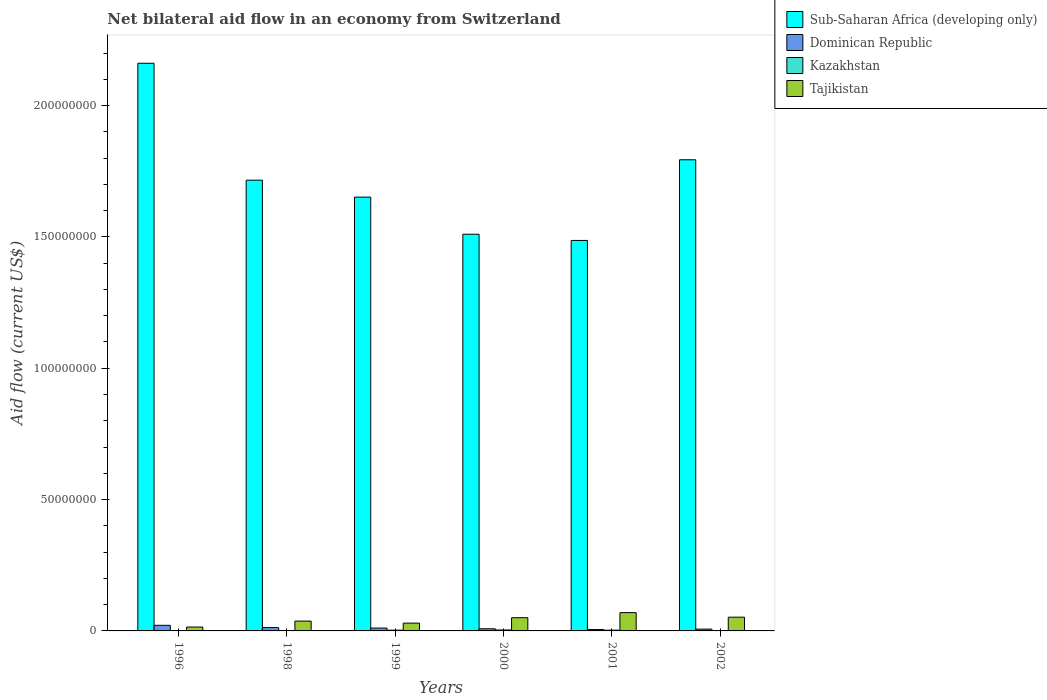How many different coloured bars are there?
Your answer should be very brief. 4. How many bars are there on the 1st tick from the left?
Make the answer very short. 4. What is the label of the 2nd group of bars from the left?
Your answer should be very brief. 1998. What is the net bilateral aid flow in Dominican Republic in 1998?
Make the answer very short. 1.27e+06. Across all years, what is the maximum net bilateral aid flow in Sub-Saharan Africa (developing only)?
Keep it short and to the point. 2.16e+08. In which year was the net bilateral aid flow in Dominican Republic minimum?
Offer a terse response. 2001. What is the total net bilateral aid flow in Sub-Saharan Africa (developing only) in the graph?
Offer a terse response. 1.03e+09. What is the difference between the net bilateral aid flow in Sub-Saharan Africa (developing only) in 1996 and the net bilateral aid flow in Tajikistan in 1999?
Ensure brevity in your answer.  2.13e+08. What is the average net bilateral aid flow in Sub-Saharan Africa (developing only) per year?
Offer a very short reply. 1.72e+08. In the year 2001, what is the difference between the net bilateral aid flow in Tajikistan and net bilateral aid flow in Sub-Saharan Africa (developing only)?
Make the answer very short. -1.42e+08. What is the ratio of the net bilateral aid flow in Kazakhstan in 1998 to that in 2001?
Make the answer very short. 0.25. Is the net bilateral aid flow in Kazakhstan in 1996 less than that in 2002?
Keep it short and to the point. Yes. What is the difference between the highest and the second highest net bilateral aid flow in Tajikistan?
Keep it short and to the point. 1.74e+06. What is the difference between the highest and the lowest net bilateral aid flow in Dominican Republic?
Give a very brief answer. 1.61e+06. In how many years, is the net bilateral aid flow in Dominican Republic greater than the average net bilateral aid flow in Dominican Republic taken over all years?
Give a very brief answer. 3. Is it the case that in every year, the sum of the net bilateral aid flow in Sub-Saharan Africa (developing only) and net bilateral aid flow in Dominican Republic is greater than the sum of net bilateral aid flow in Tajikistan and net bilateral aid flow in Kazakhstan?
Provide a succinct answer. No. What does the 3rd bar from the left in 1999 represents?
Keep it short and to the point. Kazakhstan. What does the 1st bar from the right in 2002 represents?
Offer a terse response. Tajikistan. Is it the case that in every year, the sum of the net bilateral aid flow in Sub-Saharan Africa (developing only) and net bilateral aid flow in Dominican Republic is greater than the net bilateral aid flow in Tajikistan?
Give a very brief answer. Yes. How many bars are there?
Offer a very short reply. 24. Does the graph contain any zero values?
Your answer should be very brief. No. Does the graph contain grids?
Keep it short and to the point. No. Where does the legend appear in the graph?
Keep it short and to the point. Top right. How many legend labels are there?
Give a very brief answer. 4. How are the legend labels stacked?
Ensure brevity in your answer.  Vertical. What is the title of the graph?
Offer a terse response. Net bilateral aid flow in an economy from Switzerland. What is the label or title of the X-axis?
Give a very brief answer. Years. What is the label or title of the Y-axis?
Your response must be concise. Aid flow (current US$). What is the Aid flow (current US$) in Sub-Saharan Africa (developing only) in 1996?
Your answer should be very brief. 2.16e+08. What is the Aid flow (current US$) of Dominican Republic in 1996?
Give a very brief answer. 2.13e+06. What is the Aid flow (current US$) of Kazakhstan in 1996?
Provide a succinct answer. 3.00e+04. What is the Aid flow (current US$) in Tajikistan in 1996?
Offer a very short reply. 1.48e+06. What is the Aid flow (current US$) in Sub-Saharan Africa (developing only) in 1998?
Give a very brief answer. 1.72e+08. What is the Aid flow (current US$) in Dominican Republic in 1998?
Your answer should be very brief. 1.27e+06. What is the Aid flow (current US$) in Tajikistan in 1998?
Provide a short and direct response. 3.74e+06. What is the Aid flow (current US$) of Sub-Saharan Africa (developing only) in 1999?
Provide a short and direct response. 1.65e+08. What is the Aid flow (current US$) in Dominican Republic in 1999?
Make the answer very short. 1.09e+06. What is the Aid flow (current US$) in Tajikistan in 1999?
Offer a terse response. 2.97e+06. What is the Aid flow (current US$) of Sub-Saharan Africa (developing only) in 2000?
Provide a succinct answer. 1.51e+08. What is the Aid flow (current US$) in Dominican Republic in 2000?
Offer a very short reply. 8.10e+05. What is the Aid flow (current US$) in Tajikistan in 2000?
Offer a very short reply. 5.04e+06. What is the Aid flow (current US$) in Sub-Saharan Africa (developing only) in 2001?
Give a very brief answer. 1.49e+08. What is the Aid flow (current US$) in Dominican Republic in 2001?
Your answer should be compact. 5.20e+05. What is the Aid flow (current US$) in Kazakhstan in 2001?
Provide a succinct answer. 2.80e+05. What is the Aid flow (current US$) of Tajikistan in 2001?
Your answer should be compact. 6.97e+06. What is the Aid flow (current US$) in Sub-Saharan Africa (developing only) in 2002?
Keep it short and to the point. 1.79e+08. What is the Aid flow (current US$) of Dominican Republic in 2002?
Your answer should be compact. 6.80e+05. What is the Aid flow (current US$) in Tajikistan in 2002?
Provide a succinct answer. 5.23e+06. Across all years, what is the maximum Aid flow (current US$) in Sub-Saharan Africa (developing only)?
Ensure brevity in your answer.  2.16e+08. Across all years, what is the maximum Aid flow (current US$) of Dominican Republic?
Give a very brief answer. 2.13e+06. Across all years, what is the maximum Aid flow (current US$) in Tajikistan?
Keep it short and to the point. 6.97e+06. Across all years, what is the minimum Aid flow (current US$) of Sub-Saharan Africa (developing only)?
Offer a terse response. 1.49e+08. Across all years, what is the minimum Aid flow (current US$) of Dominican Republic?
Your answer should be very brief. 5.20e+05. Across all years, what is the minimum Aid flow (current US$) in Kazakhstan?
Provide a succinct answer. 3.00e+04. Across all years, what is the minimum Aid flow (current US$) of Tajikistan?
Offer a very short reply. 1.48e+06. What is the total Aid flow (current US$) of Sub-Saharan Africa (developing only) in the graph?
Your answer should be very brief. 1.03e+09. What is the total Aid flow (current US$) of Dominican Republic in the graph?
Make the answer very short. 6.50e+06. What is the total Aid flow (current US$) of Kazakhstan in the graph?
Your answer should be compact. 1.14e+06. What is the total Aid flow (current US$) in Tajikistan in the graph?
Your answer should be very brief. 2.54e+07. What is the difference between the Aid flow (current US$) in Sub-Saharan Africa (developing only) in 1996 and that in 1998?
Ensure brevity in your answer.  4.45e+07. What is the difference between the Aid flow (current US$) in Dominican Republic in 1996 and that in 1998?
Ensure brevity in your answer.  8.60e+05. What is the difference between the Aid flow (current US$) in Kazakhstan in 1996 and that in 1998?
Your answer should be compact. -4.00e+04. What is the difference between the Aid flow (current US$) in Tajikistan in 1996 and that in 1998?
Your answer should be compact. -2.26e+06. What is the difference between the Aid flow (current US$) in Sub-Saharan Africa (developing only) in 1996 and that in 1999?
Provide a succinct answer. 5.10e+07. What is the difference between the Aid flow (current US$) of Dominican Republic in 1996 and that in 1999?
Offer a terse response. 1.04e+06. What is the difference between the Aid flow (current US$) in Tajikistan in 1996 and that in 1999?
Your answer should be very brief. -1.49e+06. What is the difference between the Aid flow (current US$) of Sub-Saharan Africa (developing only) in 1996 and that in 2000?
Offer a terse response. 6.51e+07. What is the difference between the Aid flow (current US$) in Dominican Republic in 1996 and that in 2000?
Offer a very short reply. 1.32e+06. What is the difference between the Aid flow (current US$) of Kazakhstan in 1996 and that in 2000?
Your response must be concise. -3.30e+05. What is the difference between the Aid flow (current US$) in Tajikistan in 1996 and that in 2000?
Your response must be concise. -3.56e+06. What is the difference between the Aid flow (current US$) in Sub-Saharan Africa (developing only) in 1996 and that in 2001?
Ensure brevity in your answer.  6.74e+07. What is the difference between the Aid flow (current US$) of Dominican Republic in 1996 and that in 2001?
Give a very brief answer. 1.61e+06. What is the difference between the Aid flow (current US$) in Tajikistan in 1996 and that in 2001?
Your answer should be compact. -5.49e+06. What is the difference between the Aid flow (current US$) of Sub-Saharan Africa (developing only) in 1996 and that in 2002?
Give a very brief answer. 3.67e+07. What is the difference between the Aid flow (current US$) of Dominican Republic in 1996 and that in 2002?
Your answer should be very brief. 1.45e+06. What is the difference between the Aid flow (current US$) in Tajikistan in 1996 and that in 2002?
Your response must be concise. -3.75e+06. What is the difference between the Aid flow (current US$) of Sub-Saharan Africa (developing only) in 1998 and that in 1999?
Ensure brevity in your answer.  6.45e+06. What is the difference between the Aid flow (current US$) in Dominican Republic in 1998 and that in 1999?
Your answer should be compact. 1.80e+05. What is the difference between the Aid flow (current US$) of Tajikistan in 1998 and that in 1999?
Your answer should be very brief. 7.70e+05. What is the difference between the Aid flow (current US$) in Sub-Saharan Africa (developing only) in 1998 and that in 2000?
Give a very brief answer. 2.06e+07. What is the difference between the Aid flow (current US$) of Tajikistan in 1998 and that in 2000?
Give a very brief answer. -1.30e+06. What is the difference between the Aid flow (current US$) of Sub-Saharan Africa (developing only) in 1998 and that in 2001?
Provide a short and direct response. 2.29e+07. What is the difference between the Aid flow (current US$) in Dominican Republic in 1998 and that in 2001?
Provide a succinct answer. 7.50e+05. What is the difference between the Aid flow (current US$) in Tajikistan in 1998 and that in 2001?
Make the answer very short. -3.23e+06. What is the difference between the Aid flow (current US$) in Sub-Saharan Africa (developing only) in 1998 and that in 2002?
Provide a short and direct response. -7.77e+06. What is the difference between the Aid flow (current US$) in Dominican Republic in 1998 and that in 2002?
Offer a very short reply. 5.90e+05. What is the difference between the Aid flow (current US$) in Tajikistan in 1998 and that in 2002?
Offer a terse response. -1.49e+06. What is the difference between the Aid flow (current US$) in Sub-Saharan Africa (developing only) in 1999 and that in 2000?
Give a very brief answer. 1.41e+07. What is the difference between the Aid flow (current US$) in Tajikistan in 1999 and that in 2000?
Provide a succinct answer. -2.07e+06. What is the difference between the Aid flow (current US$) of Sub-Saharan Africa (developing only) in 1999 and that in 2001?
Offer a very short reply. 1.65e+07. What is the difference between the Aid flow (current US$) of Dominican Republic in 1999 and that in 2001?
Offer a terse response. 5.70e+05. What is the difference between the Aid flow (current US$) of Sub-Saharan Africa (developing only) in 1999 and that in 2002?
Make the answer very short. -1.42e+07. What is the difference between the Aid flow (current US$) in Kazakhstan in 1999 and that in 2002?
Your response must be concise. 1.60e+05. What is the difference between the Aid flow (current US$) of Tajikistan in 1999 and that in 2002?
Your answer should be very brief. -2.26e+06. What is the difference between the Aid flow (current US$) of Sub-Saharan Africa (developing only) in 2000 and that in 2001?
Offer a very short reply. 2.36e+06. What is the difference between the Aid flow (current US$) in Tajikistan in 2000 and that in 2001?
Make the answer very short. -1.93e+06. What is the difference between the Aid flow (current US$) of Sub-Saharan Africa (developing only) in 2000 and that in 2002?
Give a very brief answer. -2.84e+07. What is the difference between the Aid flow (current US$) of Kazakhstan in 2000 and that in 2002?
Offer a terse response. 2.40e+05. What is the difference between the Aid flow (current US$) of Sub-Saharan Africa (developing only) in 2001 and that in 2002?
Your answer should be compact. -3.07e+07. What is the difference between the Aid flow (current US$) of Kazakhstan in 2001 and that in 2002?
Offer a terse response. 1.60e+05. What is the difference between the Aid flow (current US$) of Tajikistan in 2001 and that in 2002?
Give a very brief answer. 1.74e+06. What is the difference between the Aid flow (current US$) in Sub-Saharan Africa (developing only) in 1996 and the Aid flow (current US$) in Dominican Republic in 1998?
Provide a succinct answer. 2.15e+08. What is the difference between the Aid flow (current US$) of Sub-Saharan Africa (developing only) in 1996 and the Aid flow (current US$) of Kazakhstan in 1998?
Offer a very short reply. 2.16e+08. What is the difference between the Aid flow (current US$) of Sub-Saharan Africa (developing only) in 1996 and the Aid flow (current US$) of Tajikistan in 1998?
Your response must be concise. 2.12e+08. What is the difference between the Aid flow (current US$) of Dominican Republic in 1996 and the Aid flow (current US$) of Kazakhstan in 1998?
Give a very brief answer. 2.06e+06. What is the difference between the Aid flow (current US$) in Dominican Republic in 1996 and the Aid flow (current US$) in Tajikistan in 1998?
Offer a terse response. -1.61e+06. What is the difference between the Aid flow (current US$) of Kazakhstan in 1996 and the Aid flow (current US$) of Tajikistan in 1998?
Ensure brevity in your answer.  -3.71e+06. What is the difference between the Aid flow (current US$) of Sub-Saharan Africa (developing only) in 1996 and the Aid flow (current US$) of Dominican Republic in 1999?
Your answer should be compact. 2.15e+08. What is the difference between the Aid flow (current US$) in Sub-Saharan Africa (developing only) in 1996 and the Aid flow (current US$) in Kazakhstan in 1999?
Offer a very short reply. 2.16e+08. What is the difference between the Aid flow (current US$) in Sub-Saharan Africa (developing only) in 1996 and the Aid flow (current US$) in Tajikistan in 1999?
Give a very brief answer. 2.13e+08. What is the difference between the Aid flow (current US$) of Dominican Republic in 1996 and the Aid flow (current US$) of Kazakhstan in 1999?
Offer a very short reply. 1.85e+06. What is the difference between the Aid flow (current US$) in Dominican Republic in 1996 and the Aid flow (current US$) in Tajikistan in 1999?
Provide a succinct answer. -8.40e+05. What is the difference between the Aid flow (current US$) of Kazakhstan in 1996 and the Aid flow (current US$) of Tajikistan in 1999?
Your answer should be compact. -2.94e+06. What is the difference between the Aid flow (current US$) of Sub-Saharan Africa (developing only) in 1996 and the Aid flow (current US$) of Dominican Republic in 2000?
Give a very brief answer. 2.15e+08. What is the difference between the Aid flow (current US$) in Sub-Saharan Africa (developing only) in 1996 and the Aid flow (current US$) in Kazakhstan in 2000?
Give a very brief answer. 2.16e+08. What is the difference between the Aid flow (current US$) in Sub-Saharan Africa (developing only) in 1996 and the Aid flow (current US$) in Tajikistan in 2000?
Make the answer very short. 2.11e+08. What is the difference between the Aid flow (current US$) in Dominican Republic in 1996 and the Aid flow (current US$) in Kazakhstan in 2000?
Your answer should be compact. 1.77e+06. What is the difference between the Aid flow (current US$) in Dominican Republic in 1996 and the Aid flow (current US$) in Tajikistan in 2000?
Ensure brevity in your answer.  -2.91e+06. What is the difference between the Aid flow (current US$) of Kazakhstan in 1996 and the Aid flow (current US$) of Tajikistan in 2000?
Keep it short and to the point. -5.01e+06. What is the difference between the Aid flow (current US$) in Sub-Saharan Africa (developing only) in 1996 and the Aid flow (current US$) in Dominican Republic in 2001?
Make the answer very short. 2.16e+08. What is the difference between the Aid flow (current US$) of Sub-Saharan Africa (developing only) in 1996 and the Aid flow (current US$) of Kazakhstan in 2001?
Provide a short and direct response. 2.16e+08. What is the difference between the Aid flow (current US$) of Sub-Saharan Africa (developing only) in 1996 and the Aid flow (current US$) of Tajikistan in 2001?
Give a very brief answer. 2.09e+08. What is the difference between the Aid flow (current US$) of Dominican Republic in 1996 and the Aid flow (current US$) of Kazakhstan in 2001?
Provide a succinct answer. 1.85e+06. What is the difference between the Aid flow (current US$) of Dominican Republic in 1996 and the Aid flow (current US$) of Tajikistan in 2001?
Offer a terse response. -4.84e+06. What is the difference between the Aid flow (current US$) in Kazakhstan in 1996 and the Aid flow (current US$) in Tajikistan in 2001?
Ensure brevity in your answer.  -6.94e+06. What is the difference between the Aid flow (current US$) of Sub-Saharan Africa (developing only) in 1996 and the Aid flow (current US$) of Dominican Republic in 2002?
Your answer should be very brief. 2.15e+08. What is the difference between the Aid flow (current US$) in Sub-Saharan Africa (developing only) in 1996 and the Aid flow (current US$) in Kazakhstan in 2002?
Offer a very short reply. 2.16e+08. What is the difference between the Aid flow (current US$) in Sub-Saharan Africa (developing only) in 1996 and the Aid flow (current US$) in Tajikistan in 2002?
Offer a terse response. 2.11e+08. What is the difference between the Aid flow (current US$) of Dominican Republic in 1996 and the Aid flow (current US$) of Kazakhstan in 2002?
Ensure brevity in your answer.  2.01e+06. What is the difference between the Aid flow (current US$) in Dominican Republic in 1996 and the Aid flow (current US$) in Tajikistan in 2002?
Your response must be concise. -3.10e+06. What is the difference between the Aid flow (current US$) of Kazakhstan in 1996 and the Aid flow (current US$) of Tajikistan in 2002?
Your response must be concise. -5.20e+06. What is the difference between the Aid flow (current US$) in Sub-Saharan Africa (developing only) in 1998 and the Aid flow (current US$) in Dominican Republic in 1999?
Offer a very short reply. 1.70e+08. What is the difference between the Aid flow (current US$) in Sub-Saharan Africa (developing only) in 1998 and the Aid flow (current US$) in Kazakhstan in 1999?
Your answer should be very brief. 1.71e+08. What is the difference between the Aid flow (current US$) in Sub-Saharan Africa (developing only) in 1998 and the Aid flow (current US$) in Tajikistan in 1999?
Give a very brief answer. 1.69e+08. What is the difference between the Aid flow (current US$) of Dominican Republic in 1998 and the Aid flow (current US$) of Kazakhstan in 1999?
Provide a succinct answer. 9.90e+05. What is the difference between the Aid flow (current US$) in Dominican Republic in 1998 and the Aid flow (current US$) in Tajikistan in 1999?
Offer a very short reply. -1.70e+06. What is the difference between the Aid flow (current US$) in Kazakhstan in 1998 and the Aid flow (current US$) in Tajikistan in 1999?
Your response must be concise. -2.90e+06. What is the difference between the Aid flow (current US$) in Sub-Saharan Africa (developing only) in 1998 and the Aid flow (current US$) in Dominican Republic in 2000?
Provide a succinct answer. 1.71e+08. What is the difference between the Aid flow (current US$) of Sub-Saharan Africa (developing only) in 1998 and the Aid flow (current US$) of Kazakhstan in 2000?
Offer a very short reply. 1.71e+08. What is the difference between the Aid flow (current US$) in Sub-Saharan Africa (developing only) in 1998 and the Aid flow (current US$) in Tajikistan in 2000?
Your response must be concise. 1.67e+08. What is the difference between the Aid flow (current US$) in Dominican Republic in 1998 and the Aid flow (current US$) in Kazakhstan in 2000?
Provide a succinct answer. 9.10e+05. What is the difference between the Aid flow (current US$) in Dominican Republic in 1998 and the Aid flow (current US$) in Tajikistan in 2000?
Give a very brief answer. -3.77e+06. What is the difference between the Aid flow (current US$) of Kazakhstan in 1998 and the Aid flow (current US$) of Tajikistan in 2000?
Provide a succinct answer. -4.97e+06. What is the difference between the Aid flow (current US$) of Sub-Saharan Africa (developing only) in 1998 and the Aid flow (current US$) of Dominican Republic in 2001?
Give a very brief answer. 1.71e+08. What is the difference between the Aid flow (current US$) in Sub-Saharan Africa (developing only) in 1998 and the Aid flow (current US$) in Kazakhstan in 2001?
Make the answer very short. 1.71e+08. What is the difference between the Aid flow (current US$) of Sub-Saharan Africa (developing only) in 1998 and the Aid flow (current US$) of Tajikistan in 2001?
Provide a succinct answer. 1.65e+08. What is the difference between the Aid flow (current US$) in Dominican Republic in 1998 and the Aid flow (current US$) in Kazakhstan in 2001?
Make the answer very short. 9.90e+05. What is the difference between the Aid flow (current US$) in Dominican Republic in 1998 and the Aid flow (current US$) in Tajikistan in 2001?
Offer a very short reply. -5.70e+06. What is the difference between the Aid flow (current US$) in Kazakhstan in 1998 and the Aid flow (current US$) in Tajikistan in 2001?
Your answer should be compact. -6.90e+06. What is the difference between the Aid flow (current US$) of Sub-Saharan Africa (developing only) in 1998 and the Aid flow (current US$) of Dominican Republic in 2002?
Provide a short and direct response. 1.71e+08. What is the difference between the Aid flow (current US$) in Sub-Saharan Africa (developing only) in 1998 and the Aid flow (current US$) in Kazakhstan in 2002?
Provide a succinct answer. 1.71e+08. What is the difference between the Aid flow (current US$) in Sub-Saharan Africa (developing only) in 1998 and the Aid flow (current US$) in Tajikistan in 2002?
Ensure brevity in your answer.  1.66e+08. What is the difference between the Aid flow (current US$) in Dominican Republic in 1998 and the Aid flow (current US$) in Kazakhstan in 2002?
Offer a terse response. 1.15e+06. What is the difference between the Aid flow (current US$) of Dominican Republic in 1998 and the Aid flow (current US$) of Tajikistan in 2002?
Ensure brevity in your answer.  -3.96e+06. What is the difference between the Aid flow (current US$) of Kazakhstan in 1998 and the Aid flow (current US$) of Tajikistan in 2002?
Provide a succinct answer. -5.16e+06. What is the difference between the Aid flow (current US$) of Sub-Saharan Africa (developing only) in 1999 and the Aid flow (current US$) of Dominican Republic in 2000?
Give a very brief answer. 1.64e+08. What is the difference between the Aid flow (current US$) of Sub-Saharan Africa (developing only) in 1999 and the Aid flow (current US$) of Kazakhstan in 2000?
Your answer should be very brief. 1.65e+08. What is the difference between the Aid flow (current US$) in Sub-Saharan Africa (developing only) in 1999 and the Aid flow (current US$) in Tajikistan in 2000?
Make the answer very short. 1.60e+08. What is the difference between the Aid flow (current US$) of Dominican Republic in 1999 and the Aid flow (current US$) of Kazakhstan in 2000?
Make the answer very short. 7.30e+05. What is the difference between the Aid flow (current US$) in Dominican Republic in 1999 and the Aid flow (current US$) in Tajikistan in 2000?
Your response must be concise. -3.95e+06. What is the difference between the Aid flow (current US$) in Kazakhstan in 1999 and the Aid flow (current US$) in Tajikistan in 2000?
Provide a succinct answer. -4.76e+06. What is the difference between the Aid flow (current US$) of Sub-Saharan Africa (developing only) in 1999 and the Aid flow (current US$) of Dominican Republic in 2001?
Offer a terse response. 1.65e+08. What is the difference between the Aid flow (current US$) in Sub-Saharan Africa (developing only) in 1999 and the Aid flow (current US$) in Kazakhstan in 2001?
Make the answer very short. 1.65e+08. What is the difference between the Aid flow (current US$) of Sub-Saharan Africa (developing only) in 1999 and the Aid flow (current US$) of Tajikistan in 2001?
Your response must be concise. 1.58e+08. What is the difference between the Aid flow (current US$) in Dominican Republic in 1999 and the Aid flow (current US$) in Kazakhstan in 2001?
Your answer should be compact. 8.10e+05. What is the difference between the Aid flow (current US$) in Dominican Republic in 1999 and the Aid flow (current US$) in Tajikistan in 2001?
Give a very brief answer. -5.88e+06. What is the difference between the Aid flow (current US$) in Kazakhstan in 1999 and the Aid flow (current US$) in Tajikistan in 2001?
Offer a terse response. -6.69e+06. What is the difference between the Aid flow (current US$) in Sub-Saharan Africa (developing only) in 1999 and the Aid flow (current US$) in Dominican Republic in 2002?
Keep it short and to the point. 1.64e+08. What is the difference between the Aid flow (current US$) of Sub-Saharan Africa (developing only) in 1999 and the Aid flow (current US$) of Kazakhstan in 2002?
Provide a short and direct response. 1.65e+08. What is the difference between the Aid flow (current US$) of Sub-Saharan Africa (developing only) in 1999 and the Aid flow (current US$) of Tajikistan in 2002?
Keep it short and to the point. 1.60e+08. What is the difference between the Aid flow (current US$) of Dominican Republic in 1999 and the Aid flow (current US$) of Kazakhstan in 2002?
Give a very brief answer. 9.70e+05. What is the difference between the Aid flow (current US$) in Dominican Republic in 1999 and the Aid flow (current US$) in Tajikistan in 2002?
Provide a short and direct response. -4.14e+06. What is the difference between the Aid flow (current US$) in Kazakhstan in 1999 and the Aid flow (current US$) in Tajikistan in 2002?
Offer a very short reply. -4.95e+06. What is the difference between the Aid flow (current US$) of Sub-Saharan Africa (developing only) in 2000 and the Aid flow (current US$) of Dominican Republic in 2001?
Keep it short and to the point. 1.50e+08. What is the difference between the Aid flow (current US$) in Sub-Saharan Africa (developing only) in 2000 and the Aid flow (current US$) in Kazakhstan in 2001?
Give a very brief answer. 1.51e+08. What is the difference between the Aid flow (current US$) of Sub-Saharan Africa (developing only) in 2000 and the Aid flow (current US$) of Tajikistan in 2001?
Provide a succinct answer. 1.44e+08. What is the difference between the Aid flow (current US$) in Dominican Republic in 2000 and the Aid flow (current US$) in Kazakhstan in 2001?
Offer a terse response. 5.30e+05. What is the difference between the Aid flow (current US$) of Dominican Republic in 2000 and the Aid flow (current US$) of Tajikistan in 2001?
Provide a succinct answer. -6.16e+06. What is the difference between the Aid flow (current US$) of Kazakhstan in 2000 and the Aid flow (current US$) of Tajikistan in 2001?
Your answer should be compact. -6.61e+06. What is the difference between the Aid flow (current US$) in Sub-Saharan Africa (developing only) in 2000 and the Aid flow (current US$) in Dominican Republic in 2002?
Your answer should be very brief. 1.50e+08. What is the difference between the Aid flow (current US$) of Sub-Saharan Africa (developing only) in 2000 and the Aid flow (current US$) of Kazakhstan in 2002?
Give a very brief answer. 1.51e+08. What is the difference between the Aid flow (current US$) in Sub-Saharan Africa (developing only) in 2000 and the Aid flow (current US$) in Tajikistan in 2002?
Offer a very short reply. 1.46e+08. What is the difference between the Aid flow (current US$) of Dominican Republic in 2000 and the Aid flow (current US$) of Kazakhstan in 2002?
Provide a succinct answer. 6.90e+05. What is the difference between the Aid flow (current US$) in Dominican Republic in 2000 and the Aid flow (current US$) in Tajikistan in 2002?
Provide a short and direct response. -4.42e+06. What is the difference between the Aid flow (current US$) of Kazakhstan in 2000 and the Aid flow (current US$) of Tajikistan in 2002?
Offer a very short reply. -4.87e+06. What is the difference between the Aid flow (current US$) of Sub-Saharan Africa (developing only) in 2001 and the Aid flow (current US$) of Dominican Republic in 2002?
Provide a succinct answer. 1.48e+08. What is the difference between the Aid flow (current US$) in Sub-Saharan Africa (developing only) in 2001 and the Aid flow (current US$) in Kazakhstan in 2002?
Make the answer very short. 1.49e+08. What is the difference between the Aid flow (current US$) of Sub-Saharan Africa (developing only) in 2001 and the Aid flow (current US$) of Tajikistan in 2002?
Make the answer very short. 1.43e+08. What is the difference between the Aid flow (current US$) of Dominican Republic in 2001 and the Aid flow (current US$) of Kazakhstan in 2002?
Provide a succinct answer. 4.00e+05. What is the difference between the Aid flow (current US$) in Dominican Republic in 2001 and the Aid flow (current US$) in Tajikistan in 2002?
Provide a succinct answer. -4.71e+06. What is the difference between the Aid flow (current US$) in Kazakhstan in 2001 and the Aid flow (current US$) in Tajikistan in 2002?
Provide a succinct answer. -4.95e+06. What is the average Aid flow (current US$) of Sub-Saharan Africa (developing only) per year?
Your answer should be compact. 1.72e+08. What is the average Aid flow (current US$) of Dominican Republic per year?
Your answer should be compact. 1.08e+06. What is the average Aid flow (current US$) of Tajikistan per year?
Provide a succinct answer. 4.24e+06. In the year 1996, what is the difference between the Aid flow (current US$) in Sub-Saharan Africa (developing only) and Aid flow (current US$) in Dominican Republic?
Offer a very short reply. 2.14e+08. In the year 1996, what is the difference between the Aid flow (current US$) in Sub-Saharan Africa (developing only) and Aid flow (current US$) in Kazakhstan?
Make the answer very short. 2.16e+08. In the year 1996, what is the difference between the Aid flow (current US$) in Sub-Saharan Africa (developing only) and Aid flow (current US$) in Tajikistan?
Provide a succinct answer. 2.15e+08. In the year 1996, what is the difference between the Aid flow (current US$) of Dominican Republic and Aid flow (current US$) of Kazakhstan?
Give a very brief answer. 2.10e+06. In the year 1996, what is the difference between the Aid flow (current US$) in Dominican Republic and Aid flow (current US$) in Tajikistan?
Keep it short and to the point. 6.50e+05. In the year 1996, what is the difference between the Aid flow (current US$) in Kazakhstan and Aid flow (current US$) in Tajikistan?
Give a very brief answer. -1.45e+06. In the year 1998, what is the difference between the Aid flow (current US$) of Sub-Saharan Africa (developing only) and Aid flow (current US$) of Dominican Republic?
Your response must be concise. 1.70e+08. In the year 1998, what is the difference between the Aid flow (current US$) in Sub-Saharan Africa (developing only) and Aid flow (current US$) in Kazakhstan?
Provide a succinct answer. 1.72e+08. In the year 1998, what is the difference between the Aid flow (current US$) of Sub-Saharan Africa (developing only) and Aid flow (current US$) of Tajikistan?
Make the answer very short. 1.68e+08. In the year 1998, what is the difference between the Aid flow (current US$) of Dominican Republic and Aid flow (current US$) of Kazakhstan?
Your response must be concise. 1.20e+06. In the year 1998, what is the difference between the Aid flow (current US$) of Dominican Republic and Aid flow (current US$) of Tajikistan?
Make the answer very short. -2.47e+06. In the year 1998, what is the difference between the Aid flow (current US$) of Kazakhstan and Aid flow (current US$) of Tajikistan?
Offer a very short reply. -3.67e+06. In the year 1999, what is the difference between the Aid flow (current US$) in Sub-Saharan Africa (developing only) and Aid flow (current US$) in Dominican Republic?
Keep it short and to the point. 1.64e+08. In the year 1999, what is the difference between the Aid flow (current US$) of Sub-Saharan Africa (developing only) and Aid flow (current US$) of Kazakhstan?
Offer a very short reply. 1.65e+08. In the year 1999, what is the difference between the Aid flow (current US$) of Sub-Saharan Africa (developing only) and Aid flow (current US$) of Tajikistan?
Give a very brief answer. 1.62e+08. In the year 1999, what is the difference between the Aid flow (current US$) of Dominican Republic and Aid flow (current US$) of Kazakhstan?
Your answer should be very brief. 8.10e+05. In the year 1999, what is the difference between the Aid flow (current US$) of Dominican Republic and Aid flow (current US$) of Tajikistan?
Your answer should be very brief. -1.88e+06. In the year 1999, what is the difference between the Aid flow (current US$) of Kazakhstan and Aid flow (current US$) of Tajikistan?
Your answer should be very brief. -2.69e+06. In the year 2000, what is the difference between the Aid flow (current US$) in Sub-Saharan Africa (developing only) and Aid flow (current US$) in Dominican Republic?
Your answer should be compact. 1.50e+08. In the year 2000, what is the difference between the Aid flow (current US$) in Sub-Saharan Africa (developing only) and Aid flow (current US$) in Kazakhstan?
Keep it short and to the point. 1.51e+08. In the year 2000, what is the difference between the Aid flow (current US$) in Sub-Saharan Africa (developing only) and Aid flow (current US$) in Tajikistan?
Provide a succinct answer. 1.46e+08. In the year 2000, what is the difference between the Aid flow (current US$) in Dominican Republic and Aid flow (current US$) in Kazakhstan?
Ensure brevity in your answer.  4.50e+05. In the year 2000, what is the difference between the Aid flow (current US$) in Dominican Republic and Aid flow (current US$) in Tajikistan?
Keep it short and to the point. -4.23e+06. In the year 2000, what is the difference between the Aid flow (current US$) in Kazakhstan and Aid flow (current US$) in Tajikistan?
Make the answer very short. -4.68e+06. In the year 2001, what is the difference between the Aid flow (current US$) in Sub-Saharan Africa (developing only) and Aid flow (current US$) in Dominican Republic?
Give a very brief answer. 1.48e+08. In the year 2001, what is the difference between the Aid flow (current US$) of Sub-Saharan Africa (developing only) and Aid flow (current US$) of Kazakhstan?
Give a very brief answer. 1.48e+08. In the year 2001, what is the difference between the Aid flow (current US$) of Sub-Saharan Africa (developing only) and Aid flow (current US$) of Tajikistan?
Offer a terse response. 1.42e+08. In the year 2001, what is the difference between the Aid flow (current US$) of Dominican Republic and Aid flow (current US$) of Kazakhstan?
Provide a short and direct response. 2.40e+05. In the year 2001, what is the difference between the Aid flow (current US$) in Dominican Republic and Aid flow (current US$) in Tajikistan?
Provide a succinct answer. -6.45e+06. In the year 2001, what is the difference between the Aid flow (current US$) in Kazakhstan and Aid flow (current US$) in Tajikistan?
Give a very brief answer. -6.69e+06. In the year 2002, what is the difference between the Aid flow (current US$) in Sub-Saharan Africa (developing only) and Aid flow (current US$) in Dominican Republic?
Offer a very short reply. 1.79e+08. In the year 2002, what is the difference between the Aid flow (current US$) of Sub-Saharan Africa (developing only) and Aid flow (current US$) of Kazakhstan?
Give a very brief answer. 1.79e+08. In the year 2002, what is the difference between the Aid flow (current US$) of Sub-Saharan Africa (developing only) and Aid flow (current US$) of Tajikistan?
Offer a terse response. 1.74e+08. In the year 2002, what is the difference between the Aid flow (current US$) of Dominican Republic and Aid flow (current US$) of Kazakhstan?
Ensure brevity in your answer.  5.60e+05. In the year 2002, what is the difference between the Aid flow (current US$) of Dominican Republic and Aid flow (current US$) of Tajikistan?
Provide a short and direct response. -4.55e+06. In the year 2002, what is the difference between the Aid flow (current US$) in Kazakhstan and Aid flow (current US$) in Tajikistan?
Make the answer very short. -5.11e+06. What is the ratio of the Aid flow (current US$) of Sub-Saharan Africa (developing only) in 1996 to that in 1998?
Provide a succinct answer. 1.26. What is the ratio of the Aid flow (current US$) in Dominican Republic in 1996 to that in 1998?
Offer a terse response. 1.68. What is the ratio of the Aid flow (current US$) of Kazakhstan in 1996 to that in 1998?
Your answer should be very brief. 0.43. What is the ratio of the Aid flow (current US$) in Tajikistan in 1996 to that in 1998?
Make the answer very short. 0.4. What is the ratio of the Aid flow (current US$) of Sub-Saharan Africa (developing only) in 1996 to that in 1999?
Make the answer very short. 1.31. What is the ratio of the Aid flow (current US$) of Dominican Republic in 1996 to that in 1999?
Give a very brief answer. 1.95. What is the ratio of the Aid flow (current US$) of Kazakhstan in 1996 to that in 1999?
Keep it short and to the point. 0.11. What is the ratio of the Aid flow (current US$) of Tajikistan in 1996 to that in 1999?
Provide a short and direct response. 0.5. What is the ratio of the Aid flow (current US$) of Sub-Saharan Africa (developing only) in 1996 to that in 2000?
Provide a short and direct response. 1.43. What is the ratio of the Aid flow (current US$) of Dominican Republic in 1996 to that in 2000?
Ensure brevity in your answer.  2.63. What is the ratio of the Aid flow (current US$) in Kazakhstan in 1996 to that in 2000?
Keep it short and to the point. 0.08. What is the ratio of the Aid flow (current US$) in Tajikistan in 1996 to that in 2000?
Your response must be concise. 0.29. What is the ratio of the Aid flow (current US$) of Sub-Saharan Africa (developing only) in 1996 to that in 2001?
Make the answer very short. 1.45. What is the ratio of the Aid flow (current US$) of Dominican Republic in 1996 to that in 2001?
Offer a terse response. 4.1. What is the ratio of the Aid flow (current US$) in Kazakhstan in 1996 to that in 2001?
Offer a very short reply. 0.11. What is the ratio of the Aid flow (current US$) in Tajikistan in 1996 to that in 2001?
Make the answer very short. 0.21. What is the ratio of the Aid flow (current US$) of Sub-Saharan Africa (developing only) in 1996 to that in 2002?
Make the answer very short. 1.2. What is the ratio of the Aid flow (current US$) of Dominican Republic in 1996 to that in 2002?
Provide a succinct answer. 3.13. What is the ratio of the Aid flow (current US$) of Tajikistan in 1996 to that in 2002?
Offer a terse response. 0.28. What is the ratio of the Aid flow (current US$) of Sub-Saharan Africa (developing only) in 1998 to that in 1999?
Provide a succinct answer. 1.04. What is the ratio of the Aid flow (current US$) of Dominican Republic in 1998 to that in 1999?
Provide a succinct answer. 1.17. What is the ratio of the Aid flow (current US$) in Kazakhstan in 1998 to that in 1999?
Provide a short and direct response. 0.25. What is the ratio of the Aid flow (current US$) in Tajikistan in 1998 to that in 1999?
Your answer should be compact. 1.26. What is the ratio of the Aid flow (current US$) of Sub-Saharan Africa (developing only) in 1998 to that in 2000?
Give a very brief answer. 1.14. What is the ratio of the Aid flow (current US$) of Dominican Republic in 1998 to that in 2000?
Offer a terse response. 1.57. What is the ratio of the Aid flow (current US$) of Kazakhstan in 1998 to that in 2000?
Offer a very short reply. 0.19. What is the ratio of the Aid flow (current US$) of Tajikistan in 1998 to that in 2000?
Your answer should be compact. 0.74. What is the ratio of the Aid flow (current US$) in Sub-Saharan Africa (developing only) in 1998 to that in 2001?
Your answer should be compact. 1.15. What is the ratio of the Aid flow (current US$) in Dominican Republic in 1998 to that in 2001?
Give a very brief answer. 2.44. What is the ratio of the Aid flow (current US$) of Kazakhstan in 1998 to that in 2001?
Your answer should be compact. 0.25. What is the ratio of the Aid flow (current US$) in Tajikistan in 1998 to that in 2001?
Offer a terse response. 0.54. What is the ratio of the Aid flow (current US$) in Sub-Saharan Africa (developing only) in 1998 to that in 2002?
Keep it short and to the point. 0.96. What is the ratio of the Aid flow (current US$) in Dominican Republic in 1998 to that in 2002?
Ensure brevity in your answer.  1.87. What is the ratio of the Aid flow (current US$) in Kazakhstan in 1998 to that in 2002?
Ensure brevity in your answer.  0.58. What is the ratio of the Aid flow (current US$) in Tajikistan in 1998 to that in 2002?
Offer a very short reply. 0.72. What is the ratio of the Aid flow (current US$) in Sub-Saharan Africa (developing only) in 1999 to that in 2000?
Provide a short and direct response. 1.09. What is the ratio of the Aid flow (current US$) in Dominican Republic in 1999 to that in 2000?
Provide a short and direct response. 1.35. What is the ratio of the Aid flow (current US$) of Kazakhstan in 1999 to that in 2000?
Ensure brevity in your answer.  0.78. What is the ratio of the Aid flow (current US$) in Tajikistan in 1999 to that in 2000?
Give a very brief answer. 0.59. What is the ratio of the Aid flow (current US$) of Sub-Saharan Africa (developing only) in 1999 to that in 2001?
Keep it short and to the point. 1.11. What is the ratio of the Aid flow (current US$) of Dominican Republic in 1999 to that in 2001?
Your answer should be compact. 2.1. What is the ratio of the Aid flow (current US$) of Kazakhstan in 1999 to that in 2001?
Give a very brief answer. 1. What is the ratio of the Aid flow (current US$) in Tajikistan in 1999 to that in 2001?
Offer a terse response. 0.43. What is the ratio of the Aid flow (current US$) of Sub-Saharan Africa (developing only) in 1999 to that in 2002?
Offer a very short reply. 0.92. What is the ratio of the Aid flow (current US$) of Dominican Republic in 1999 to that in 2002?
Give a very brief answer. 1.6. What is the ratio of the Aid flow (current US$) in Kazakhstan in 1999 to that in 2002?
Make the answer very short. 2.33. What is the ratio of the Aid flow (current US$) of Tajikistan in 1999 to that in 2002?
Ensure brevity in your answer.  0.57. What is the ratio of the Aid flow (current US$) in Sub-Saharan Africa (developing only) in 2000 to that in 2001?
Give a very brief answer. 1.02. What is the ratio of the Aid flow (current US$) in Dominican Republic in 2000 to that in 2001?
Your answer should be very brief. 1.56. What is the ratio of the Aid flow (current US$) in Tajikistan in 2000 to that in 2001?
Your answer should be compact. 0.72. What is the ratio of the Aid flow (current US$) in Sub-Saharan Africa (developing only) in 2000 to that in 2002?
Your answer should be compact. 0.84. What is the ratio of the Aid flow (current US$) of Dominican Republic in 2000 to that in 2002?
Offer a terse response. 1.19. What is the ratio of the Aid flow (current US$) in Tajikistan in 2000 to that in 2002?
Offer a very short reply. 0.96. What is the ratio of the Aid flow (current US$) in Sub-Saharan Africa (developing only) in 2001 to that in 2002?
Provide a short and direct response. 0.83. What is the ratio of the Aid flow (current US$) of Dominican Republic in 2001 to that in 2002?
Offer a terse response. 0.76. What is the ratio of the Aid flow (current US$) of Kazakhstan in 2001 to that in 2002?
Make the answer very short. 2.33. What is the ratio of the Aid flow (current US$) of Tajikistan in 2001 to that in 2002?
Your answer should be very brief. 1.33. What is the difference between the highest and the second highest Aid flow (current US$) of Sub-Saharan Africa (developing only)?
Provide a succinct answer. 3.67e+07. What is the difference between the highest and the second highest Aid flow (current US$) in Dominican Republic?
Your response must be concise. 8.60e+05. What is the difference between the highest and the second highest Aid flow (current US$) of Tajikistan?
Offer a terse response. 1.74e+06. What is the difference between the highest and the lowest Aid flow (current US$) in Sub-Saharan Africa (developing only)?
Provide a short and direct response. 6.74e+07. What is the difference between the highest and the lowest Aid flow (current US$) in Dominican Republic?
Your response must be concise. 1.61e+06. What is the difference between the highest and the lowest Aid flow (current US$) of Tajikistan?
Your answer should be compact. 5.49e+06. 